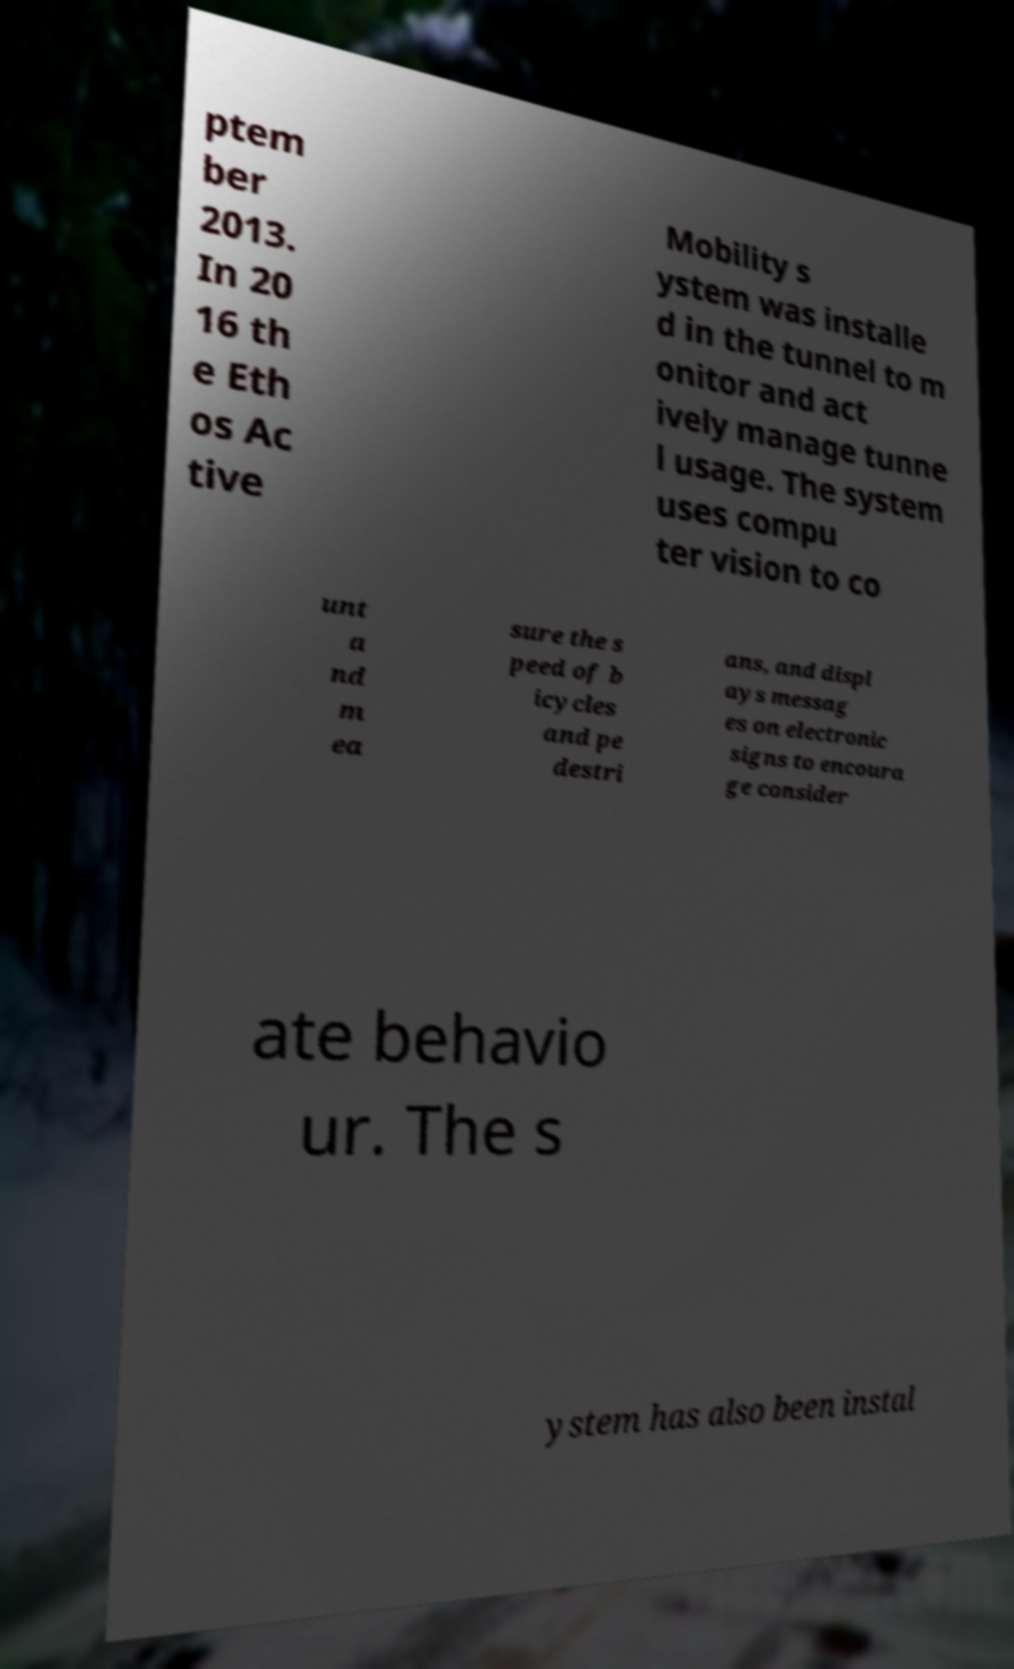For documentation purposes, I need the text within this image transcribed. Could you provide that? ptem ber 2013. In 20 16 th e Eth os Ac tive Mobility s ystem was installe d in the tunnel to m onitor and act ively manage tunne l usage. The system uses compu ter vision to co unt a nd m ea sure the s peed of b icycles and pe destri ans, and displ ays messag es on electronic signs to encoura ge consider ate behavio ur. The s ystem has also been instal 